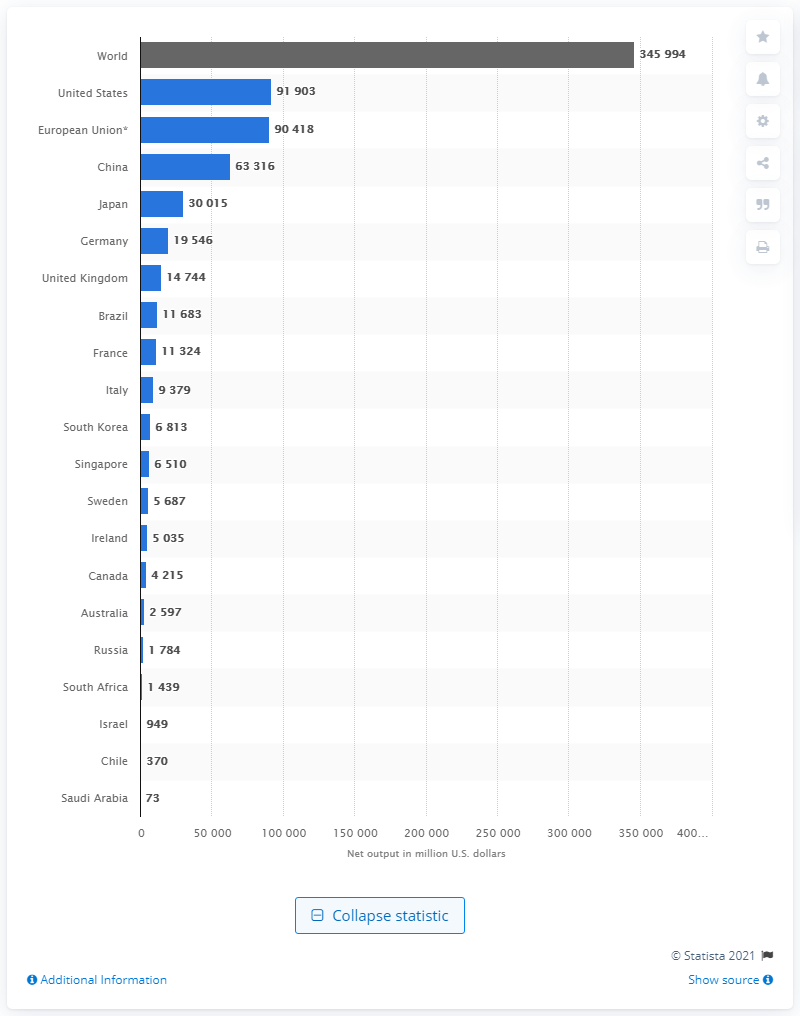Which country had the highest pharmaceutical output according to this chart? According to the chart, the United States had the highest pharmaceutical output among the listed countries. How does the European Union's output compare to that of China? The European Union's pharmaceutical output is higher than that of China according to the chart, with the EU positioned just slightly below the United States. 